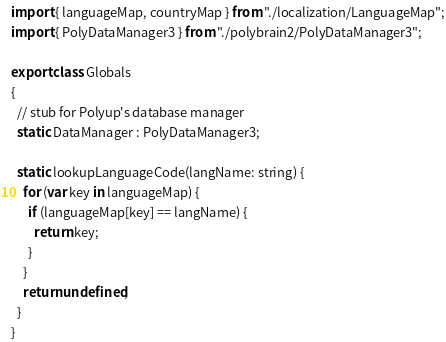<code> <loc_0><loc_0><loc_500><loc_500><_TypeScript_>import { languageMap, countryMap } from "./localization/LanguageMap";
import { PolyDataManager3 } from "./polybrain2/PolyDataManager3";

export class Globals
{
  // stub for Polyup's database manager
  static DataManager : PolyDataManager3;

  static lookupLanguageCode(langName: string) {
    for (var key in languageMap) {
      if (languageMap[key] == langName) {
        return key;
      }
    }
    return undefined;
  }
}
</code> 